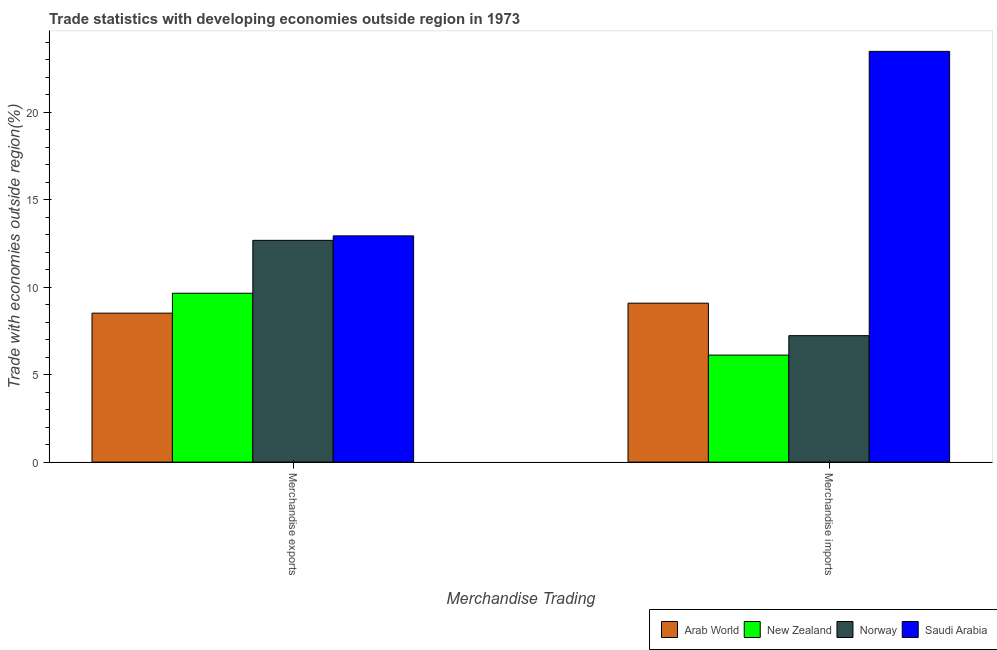Are the number of bars on each tick of the X-axis equal?
Ensure brevity in your answer.  Yes. How many bars are there on the 2nd tick from the left?
Your answer should be very brief. 4. How many bars are there on the 1st tick from the right?
Provide a succinct answer. 4. What is the label of the 2nd group of bars from the left?
Offer a terse response. Merchandise imports. What is the merchandise imports in Norway?
Keep it short and to the point. 7.23. Across all countries, what is the maximum merchandise imports?
Make the answer very short. 23.49. Across all countries, what is the minimum merchandise imports?
Offer a very short reply. 6.12. In which country was the merchandise imports maximum?
Offer a terse response. Saudi Arabia. In which country was the merchandise exports minimum?
Your answer should be very brief. Arab World. What is the total merchandise exports in the graph?
Give a very brief answer. 43.79. What is the difference between the merchandise exports in Saudi Arabia and that in Norway?
Offer a terse response. 0.26. What is the difference between the merchandise imports in Norway and the merchandise exports in New Zealand?
Offer a terse response. -2.43. What is the average merchandise imports per country?
Give a very brief answer. 11.48. What is the difference between the merchandise imports and merchandise exports in Norway?
Offer a terse response. -5.45. In how many countries, is the merchandise exports greater than 10 %?
Provide a short and direct response. 2. What is the ratio of the merchandise exports in Norway to that in Arab World?
Ensure brevity in your answer.  1.49. In how many countries, is the merchandise imports greater than the average merchandise imports taken over all countries?
Make the answer very short. 1. What does the 1st bar from the right in Merchandise imports represents?
Keep it short and to the point. Saudi Arabia. How many bars are there?
Provide a succinct answer. 8. How many countries are there in the graph?
Ensure brevity in your answer.  4. Does the graph contain any zero values?
Provide a short and direct response. No. Where does the legend appear in the graph?
Provide a succinct answer. Bottom right. How are the legend labels stacked?
Provide a short and direct response. Horizontal. What is the title of the graph?
Give a very brief answer. Trade statistics with developing economies outside region in 1973. What is the label or title of the X-axis?
Make the answer very short. Merchandise Trading. What is the label or title of the Y-axis?
Your answer should be very brief. Trade with economies outside region(%). What is the Trade with economies outside region(%) in Arab World in Merchandise exports?
Give a very brief answer. 8.52. What is the Trade with economies outside region(%) in New Zealand in Merchandise exports?
Offer a very short reply. 9.66. What is the Trade with economies outside region(%) in Norway in Merchandise exports?
Offer a very short reply. 12.68. What is the Trade with economies outside region(%) in Saudi Arabia in Merchandise exports?
Your response must be concise. 12.94. What is the Trade with economies outside region(%) in Arab World in Merchandise imports?
Provide a succinct answer. 9.09. What is the Trade with economies outside region(%) of New Zealand in Merchandise imports?
Provide a succinct answer. 6.12. What is the Trade with economies outside region(%) of Norway in Merchandise imports?
Make the answer very short. 7.23. What is the Trade with economies outside region(%) of Saudi Arabia in Merchandise imports?
Give a very brief answer. 23.49. Across all Merchandise Trading, what is the maximum Trade with economies outside region(%) in Arab World?
Provide a short and direct response. 9.09. Across all Merchandise Trading, what is the maximum Trade with economies outside region(%) in New Zealand?
Give a very brief answer. 9.66. Across all Merchandise Trading, what is the maximum Trade with economies outside region(%) in Norway?
Your answer should be very brief. 12.68. Across all Merchandise Trading, what is the maximum Trade with economies outside region(%) of Saudi Arabia?
Ensure brevity in your answer.  23.49. Across all Merchandise Trading, what is the minimum Trade with economies outside region(%) of Arab World?
Your answer should be very brief. 8.52. Across all Merchandise Trading, what is the minimum Trade with economies outside region(%) in New Zealand?
Your answer should be very brief. 6.12. Across all Merchandise Trading, what is the minimum Trade with economies outside region(%) of Norway?
Keep it short and to the point. 7.23. Across all Merchandise Trading, what is the minimum Trade with economies outside region(%) of Saudi Arabia?
Provide a succinct answer. 12.94. What is the total Trade with economies outside region(%) of Arab World in the graph?
Make the answer very short. 17.61. What is the total Trade with economies outside region(%) in New Zealand in the graph?
Keep it short and to the point. 15.78. What is the total Trade with economies outside region(%) of Norway in the graph?
Keep it short and to the point. 19.91. What is the total Trade with economies outside region(%) in Saudi Arabia in the graph?
Ensure brevity in your answer.  36.42. What is the difference between the Trade with economies outside region(%) in Arab World in Merchandise exports and that in Merchandise imports?
Give a very brief answer. -0.57. What is the difference between the Trade with economies outside region(%) of New Zealand in Merchandise exports and that in Merchandise imports?
Your answer should be compact. 3.54. What is the difference between the Trade with economies outside region(%) in Norway in Merchandise exports and that in Merchandise imports?
Ensure brevity in your answer.  5.45. What is the difference between the Trade with economies outside region(%) of Saudi Arabia in Merchandise exports and that in Merchandise imports?
Make the answer very short. -10.55. What is the difference between the Trade with economies outside region(%) of Arab World in Merchandise exports and the Trade with economies outside region(%) of New Zealand in Merchandise imports?
Your answer should be very brief. 2.4. What is the difference between the Trade with economies outside region(%) of Arab World in Merchandise exports and the Trade with economies outside region(%) of Norway in Merchandise imports?
Provide a short and direct response. 1.29. What is the difference between the Trade with economies outside region(%) in Arab World in Merchandise exports and the Trade with economies outside region(%) in Saudi Arabia in Merchandise imports?
Your response must be concise. -14.97. What is the difference between the Trade with economies outside region(%) in New Zealand in Merchandise exports and the Trade with economies outside region(%) in Norway in Merchandise imports?
Make the answer very short. 2.43. What is the difference between the Trade with economies outside region(%) of New Zealand in Merchandise exports and the Trade with economies outside region(%) of Saudi Arabia in Merchandise imports?
Keep it short and to the point. -13.83. What is the difference between the Trade with economies outside region(%) of Norway in Merchandise exports and the Trade with economies outside region(%) of Saudi Arabia in Merchandise imports?
Make the answer very short. -10.81. What is the average Trade with economies outside region(%) of Arab World per Merchandise Trading?
Offer a very short reply. 8.8. What is the average Trade with economies outside region(%) of New Zealand per Merchandise Trading?
Your answer should be very brief. 7.89. What is the average Trade with economies outside region(%) of Norway per Merchandise Trading?
Offer a very short reply. 9.96. What is the average Trade with economies outside region(%) in Saudi Arabia per Merchandise Trading?
Your answer should be very brief. 18.21. What is the difference between the Trade with economies outside region(%) in Arab World and Trade with economies outside region(%) in New Zealand in Merchandise exports?
Your answer should be very brief. -1.14. What is the difference between the Trade with economies outside region(%) of Arab World and Trade with economies outside region(%) of Norway in Merchandise exports?
Your answer should be very brief. -4.16. What is the difference between the Trade with economies outside region(%) in Arab World and Trade with economies outside region(%) in Saudi Arabia in Merchandise exports?
Ensure brevity in your answer.  -4.42. What is the difference between the Trade with economies outside region(%) of New Zealand and Trade with economies outside region(%) of Norway in Merchandise exports?
Keep it short and to the point. -3.02. What is the difference between the Trade with economies outside region(%) of New Zealand and Trade with economies outside region(%) of Saudi Arabia in Merchandise exports?
Give a very brief answer. -3.28. What is the difference between the Trade with economies outside region(%) in Norway and Trade with economies outside region(%) in Saudi Arabia in Merchandise exports?
Your answer should be very brief. -0.26. What is the difference between the Trade with economies outside region(%) of Arab World and Trade with economies outside region(%) of New Zealand in Merchandise imports?
Offer a very short reply. 2.97. What is the difference between the Trade with economies outside region(%) of Arab World and Trade with economies outside region(%) of Norway in Merchandise imports?
Your answer should be very brief. 1.86. What is the difference between the Trade with economies outside region(%) of Arab World and Trade with economies outside region(%) of Saudi Arabia in Merchandise imports?
Ensure brevity in your answer.  -14.4. What is the difference between the Trade with economies outside region(%) of New Zealand and Trade with economies outside region(%) of Norway in Merchandise imports?
Keep it short and to the point. -1.11. What is the difference between the Trade with economies outside region(%) of New Zealand and Trade with economies outside region(%) of Saudi Arabia in Merchandise imports?
Make the answer very short. -17.37. What is the difference between the Trade with economies outside region(%) of Norway and Trade with economies outside region(%) of Saudi Arabia in Merchandise imports?
Your response must be concise. -16.26. What is the ratio of the Trade with economies outside region(%) in Arab World in Merchandise exports to that in Merchandise imports?
Give a very brief answer. 0.94. What is the ratio of the Trade with economies outside region(%) of New Zealand in Merchandise exports to that in Merchandise imports?
Keep it short and to the point. 1.58. What is the ratio of the Trade with economies outside region(%) in Norway in Merchandise exports to that in Merchandise imports?
Your answer should be very brief. 1.75. What is the ratio of the Trade with economies outside region(%) of Saudi Arabia in Merchandise exports to that in Merchandise imports?
Your answer should be compact. 0.55. What is the difference between the highest and the second highest Trade with economies outside region(%) in Arab World?
Make the answer very short. 0.57. What is the difference between the highest and the second highest Trade with economies outside region(%) in New Zealand?
Your answer should be very brief. 3.54. What is the difference between the highest and the second highest Trade with economies outside region(%) of Norway?
Your response must be concise. 5.45. What is the difference between the highest and the second highest Trade with economies outside region(%) of Saudi Arabia?
Offer a very short reply. 10.55. What is the difference between the highest and the lowest Trade with economies outside region(%) of Arab World?
Make the answer very short. 0.57. What is the difference between the highest and the lowest Trade with economies outside region(%) in New Zealand?
Your response must be concise. 3.54. What is the difference between the highest and the lowest Trade with economies outside region(%) of Norway?
Offer a very short reply. 5.45. What is the difference between the highest and the lowest Trade with economies outside region(%) of Saudi Arabia?
Offer a very short reply. 10.55. 